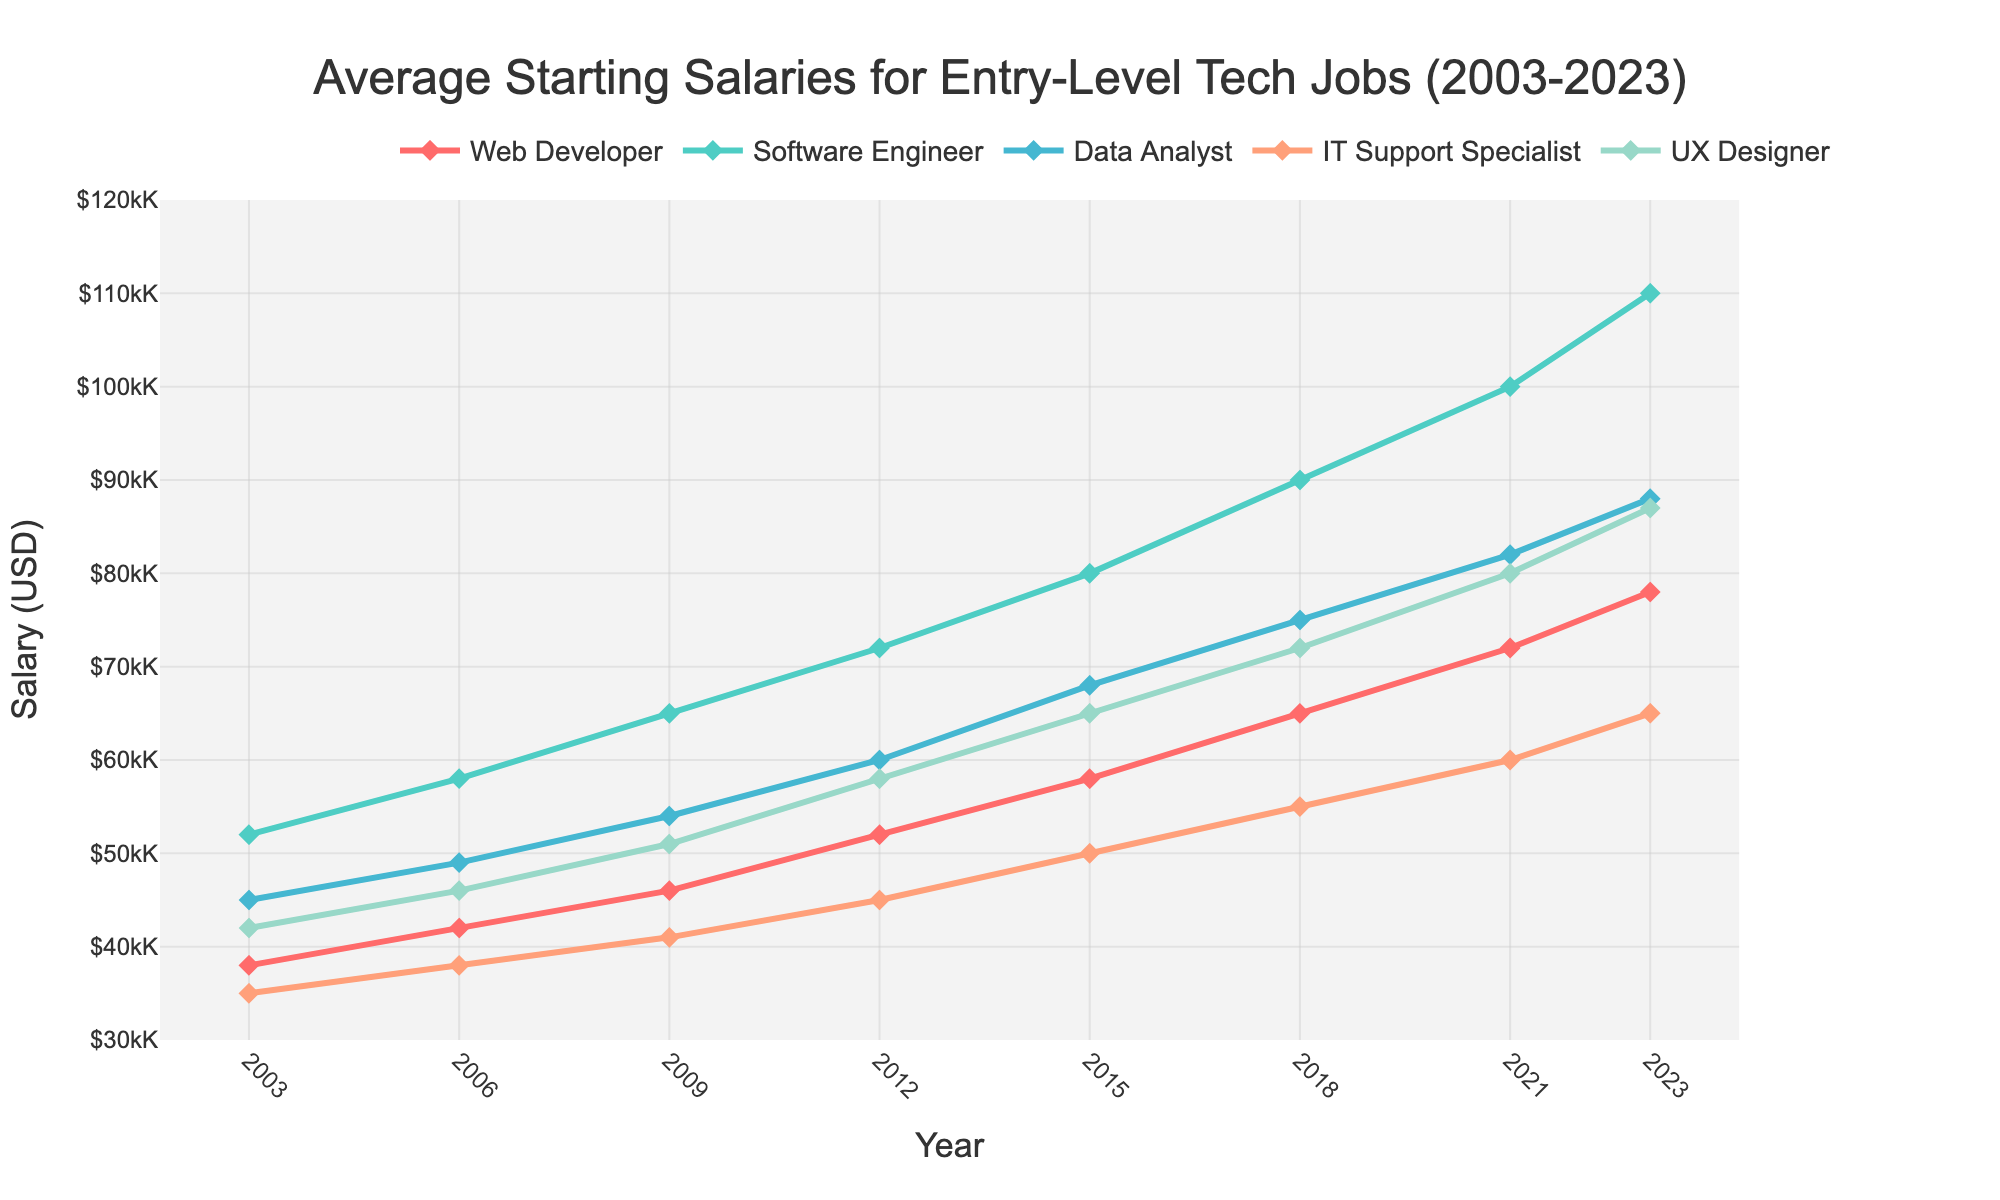What was the starting salary for a Web Developer in 2015? Find the Web Developer line on the chart and locate the year 2015. The corresponding y-value gives the salary.
Answer: $58,000 Which job had the highest starting salary in 2023? Look at the data points for all jobs in the year 2023 and identify the highest value.
Answer: Software Engineer Compare the salary growth of a Data Analyst and an IT Support Specialist from 2003 to 2023. Subtract the 2003 salary from the 2023 salary for both roles and compare the differences: Data Analyst (88000 - 45000) = 43000, IT Support Specialist (65000 - 35000) = 30000
Answer: Data Analyst had higher growth By how much did the starting salary for a UX Designer increase from 2003 to 2023? Subtract the 2003 salary from the 2023 salary for a UX Designer: 87000 - 42000
Answer: $45,000 Which job had the smallest salary increase over the 20 years? Calculate the salary increase for each job by subtracting the 2003 values from their 2023 values, then identify the smallest increase: Web Developer (78000 - 38000), Software Engineer (110000 - 52000), Data Analyst (88000 - 45000), IT Support Specialist (65000 - 35000), UX Designer (87000 - 42000)
Answer: IT Support Specialist During which period did the salary of a Software Engineer see the most rapid increase in terms of absolute value? Check the differences in salary for each period for a Software Engineer and compare them: 52000 -> 58000 -> 65000 -> 72000 -> 80000 -> 90000 -> 100000 -> 110000. The largest increase is from 2021 to 2023 (110000 - 100000)
Answer: 2021-2023 What was the average starting salary for an IT Support Specialist in 2009 and 2023? Find the yearly salaries and calculate the average: (41000 + 65000) / 2
Answer: $53,000 Which job consistently had the lowest starting salary throughout the 20 years? Check the lines on the chart to see which job mostly stayed at the bottom: look at IT Support Specialist's positions compared to others.
Answer: IT Support Specialist What is the percentage increase in salary for a Web Developer from 2003 to 2023? Calculate the percentage: ((78000-38000) / 38000) * 100% = 105.26%
Answer: 105.26% In 2018, how much higher was the starting salary for a Software Engineer than a Data Analyst? Locate the 2018 salaries for both jobs and subtract: 90000 - 75000 = 15000
Answer: $15,000 